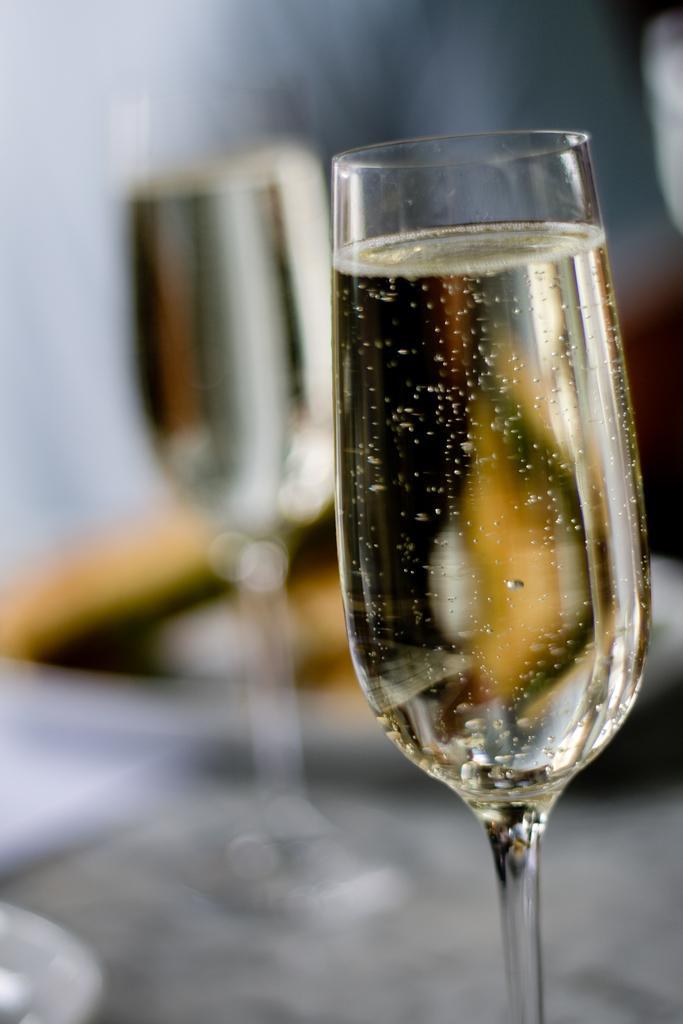In one or two sentences, can you explain what this image depicts? In this picture we observe two wine glasses kept on the table. 